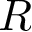Convert formula to latex. <formula><loc_0><loc_0><loc_500><loc_500>R</formula> 